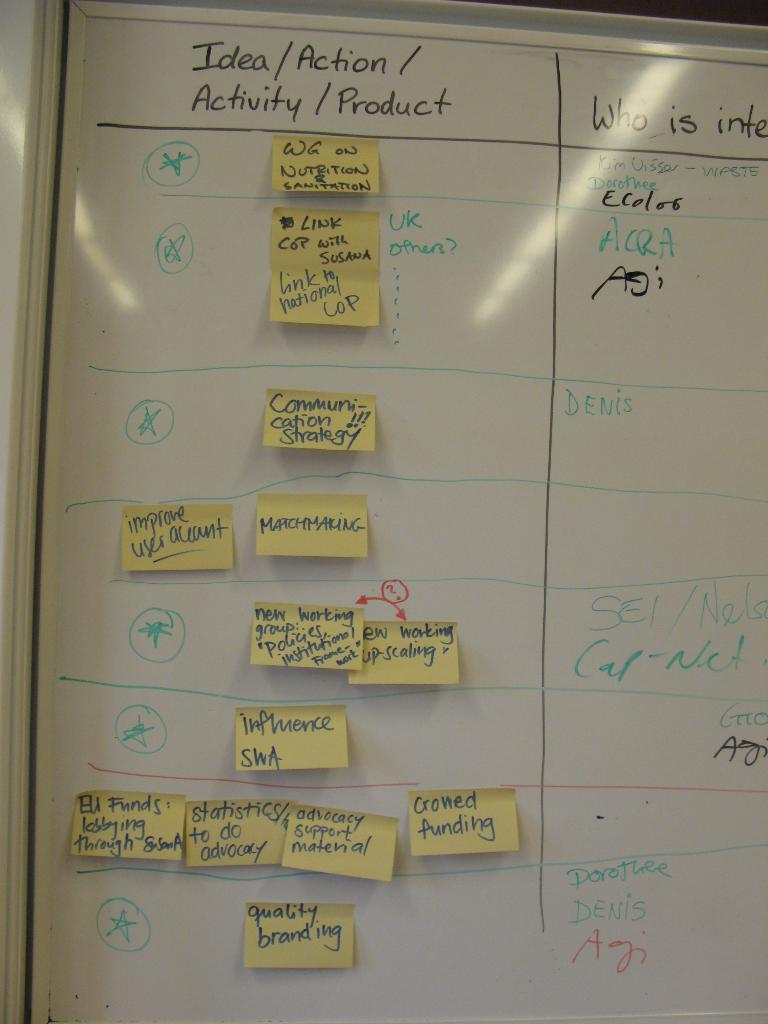<image>
Relay a brief, clear account of the picture shown. idea board with different options listed as well as sticky notes 